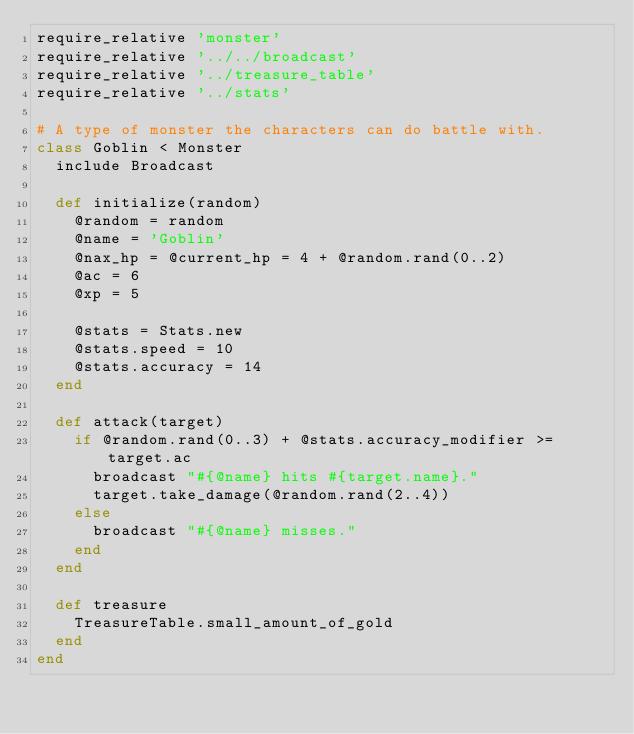Convert code to text. <code><loc_0><loc_0><loc_500><loc_500><_Ruby_>require_relative 'monster'
require_relative '../../broadcast'
require_relative '../treasure_table'
require_relative '../stats'

# A type of monster the characters can do battle with.
class Goblin < Monster
  include Broadcast

  def initialize(random)
    @random = random
    @name = 'Goblin'
    @nax_hp = @current_hp = 4 + @random.rand(0..2)
    @ac = 6
    @xp = 5

    @stats = Stats.new
    @stats.speed = 10
    @stats.accuracy = 14
  end

  def attack(target)
    if @random.rand(0..3) + @stats.accuracy_modifier >= target.ac
      broadcast "#{@name} hits #{target.name}."
      target.take_damage(@random.rand(2..4))
    else
      broadcast "#{@name} misses."
    end
  end

  def treasure
    TreasureTable.small_amount_of_gold
  end
end
</code> 